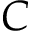<formula> <loc_0><loc_0><loc_500><loc_500>C</formula> 